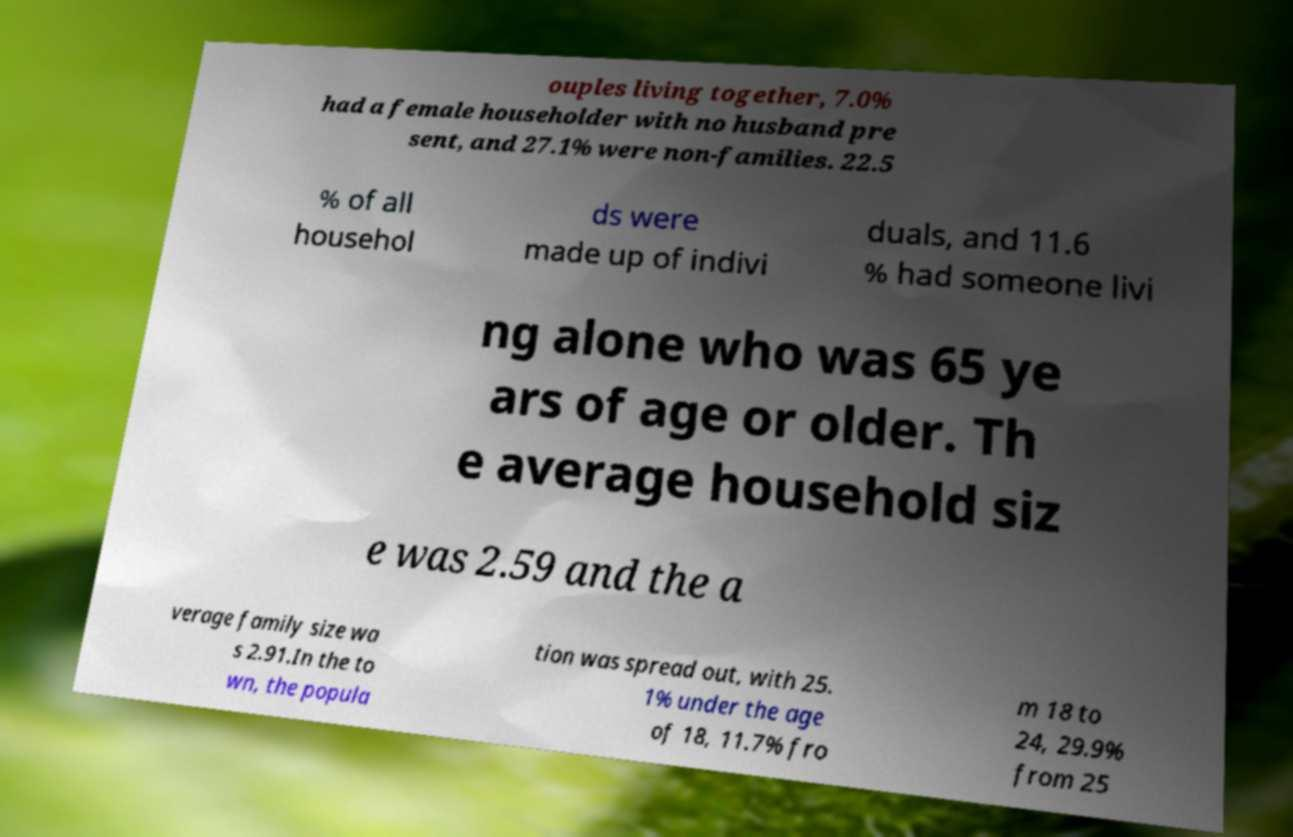Can you read and provide the text displayed in the image?This photo seems to have some interesting text. Can you extract and type it out for me? ouples living together, 7.0% had a female householder with no husband pre sent, and 27.1% were non-families. 22.5 % of all househol ds were made up of indivi duals, and 11.6 % had someone livi ng alone who was 65 ye ars of age or older. Th e average household siz e was 2.59 and the a verage family size wa s 2.91.In the to wn, the popula tion was spread out, with 25. 1% under the age of 18, 11.7% fro m 18 to 24, 29.9% from 25 